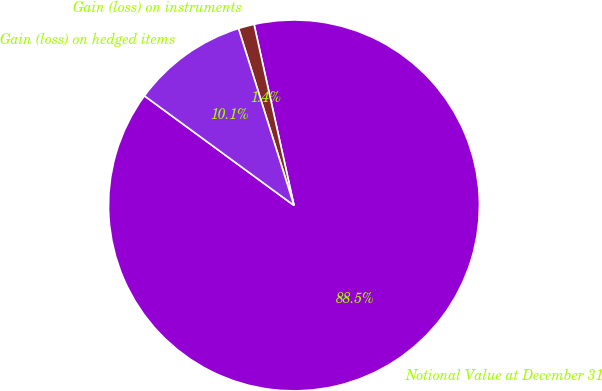<chart> <loc_0><loc_0><loc_500><loc_500><pie_chart><fcel>Notional Value at December 31<fcel>Gain (loss) on instruments<fcel>Gain (loss) on hedged items<nl><fcel>88.52%<fcel>1.38%<fcel>10.1%<nl></chart> 